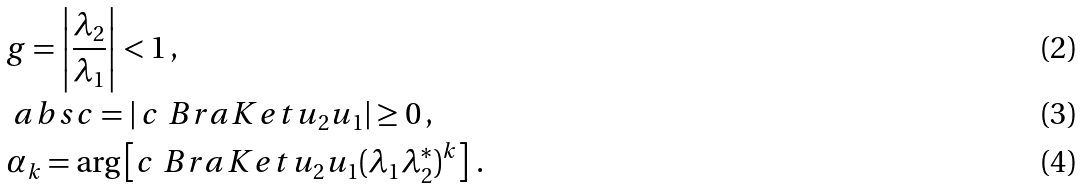Convert formula to latex. <formula><loc_0><loc_0><loc_500><loc_500>& g = \left | \frac { \lambda _ { 2 } } { \lambda _ { 1 } } \right | < 1 \, , \\ & \ a b s c = | \, c \ B r a K e t { u _ { 2 } } { u _ { 1 } } | \geq 0 \, , \\ & \alpha _ { k } = \arg \left [ c \ B r a K e t { u _ { 2 } } { u _ { 1 } } ( \lambda _ { 1 } \lambda _ { 2 } ^ { * } ) ^ { k } \right ] \, .</formula> 